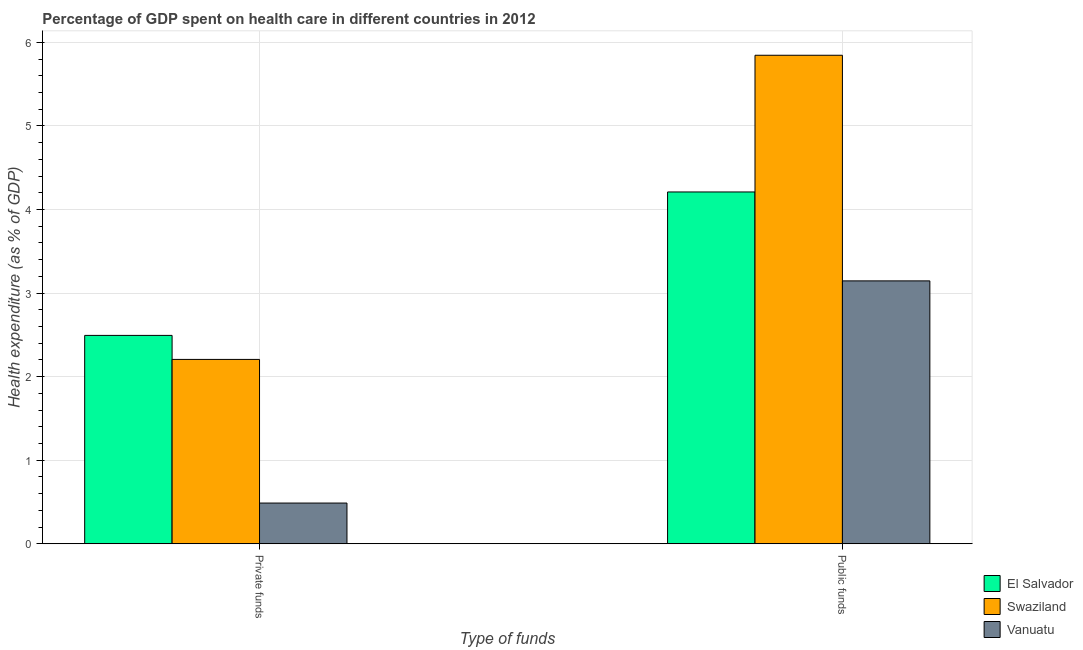How many groups of bars are there?
Offer a terse response. 2. Are the number of bars on each tick of the X-axis equal?
Provide a short and direct response. Yes. How many bars are there on the 1st tick from the left?
Provide a short and direct response. 3. What is the label of the 1st group of bars from the left?
Provide a succinct answer. Private funds. What is the amount of private funds spent in healthcare in El Salvador?
Provide a short and direct response. 2.49. Across all countries, what is the maximum amount of public funds spent in healthcare?
Offer a very short reply. 5.85. Across all countries, what is the minimum amount of public funds spent in healthcare?
Your answer should be very brief. 3.15. In which country was the amount of private funds spent in healthcare maximum?
Your answer should be compact. El Salvador. In which country was the amount of private funds spent in healthcare minimum?
Provide a short and direct response. Vanuatu. What is the total amount of private funds spent in healthcare in the graph?
Ensure brevity in your answer.  5.19. What is the difference between the amount of private funds spent in healthcare in Swaziland and that in Vanuatu?
Offer a terse response. 1.72. What is the difference between the amount of private funds spent in healthcare in Swaziland and the amount of public funds spent in healthcare in Vanuatu?
Your response must be concise. -0.94. What is the average amount of public funds spent in healthcare per country?
Your answer should be compact. 4.4. What is the difference between the amount of public funds spent in healthcare and amount of private funds spent in healthcare in Vanuatu?
Ensure brevity in your answer.  2.66. In how many countries, is the amount of public funds spent in healthcare greater than 5.8 %?
Make the answer very short. 1. What is the ratio of the amount of public funds spent in healthcare in Vanuatu to that in Swaziland?
Give a very brief answer. 0.54. Is the amount of private funds spent in healthcare in Swaziland less than that in Vanuatu?
Ensure brevity in your answer.  No. What does the 2nd bar from the left in Public funds represents?
Your answer should be very brief. Swaziland. What does the 3rd bar from the right in Public funds represents?
Your answer should be compact. El Salvador. Are all the bars in the graph horizontal?
Your answer should be compact. No. What is the difference between two consecutive major ticks on the Y-axis?
Keep it short and to the point. 1. Does the graph contain grids?
Provide a short and direct response. Yes. How many legend labels are there?
Provide a succinct answer. 3. How are the legend labels stacked?
Give a very brief answer. Vertical. What is the title of the graph?
Make the answer very short. Percentage of GDP spent on health care in different countries in 2012. What is the label or title of the X-axis?
Your answer should be compact. Type of funds. What is the label or title of the Y-axis?
Make the answer very short. Health expenditure (as % of GDP). What is the Health expenditure (as % of GDP) of El Salvador in Private funds?
Offer a terse response. 2.49. What is the Health expenditure (as % of GDP) in Swaziland in Private funds?
Make the answer very short. 2.21. What is the Health expenditure (as % of GDP) of Vanuatu in Private funds?
Provide a short and direct response. 0.49. What is the Health expenditure (as % of GDP) of El Salvador in Public funds?
Provide a succinct answer. 4.21. What is the Health expenditure (as % of GDP) in Swaziland in Public funds?
Offer a very short reply. 5.85. What is the Health expenditure (as % of GDP) in Vanuatu in Public funds?
Offer a very short reply. 3.15. Across all Type of funds, what is the maximum Health expenditure (as % of GDP) in El Salvador?
Provide a succinct answer. 4.21. Across all Type of funds, what is the maximum Health expenditure (as % of GDP) of Swaziland?
Make the answer very short. 5.85. Across all Type of funds, what is the maximum Health expenditure (as % of GDP) in Vanuatu?
Provide a succinct answer. 3.15. Across all Type of funds, what is the minimum Health expenditure (as % of GDP) in El Salvador?
Provide a short and direct response. 2.49. Across all Type of funds, what is the minimum Health expenditure (as % of GDP) of Swaziland?
Make the answer very short. 2.21. Across all Type of funds, what is the minimum Health expenditure (as % of GDP) in Vanuatu?
Give a very brief answer. 0.49. What is the total Health expenditure (as % of GDP) of El Salvador in the graph?
Provide a short and direct response. 6.7. What is the total Health expenditure (as % of GDP) of Swaziland in the graph?
Offer a terse response. 8.05. What is the total Health expenditure (as % of GDP) in Vanuatu in the graph?
Offer a terse response. 3.63. What is the difference between the Health expenditure (as % of GDP) in El Salvador in Private funds and that in Public funds?
Give a very brief answer. -1.72. What is the difference between the Health expenditure (as % of GDP) in Swaziland in Private funds and that in Public funds?
Your answer should be very brief. -3.64. What is the difference between the Health expenditure (as % of GDP) of Vanuatu in Private funds and that in Public funds?
Provide a short and direct response. -2.66. What is the difference between the Health expenditure (as % of GDP) in El Salvador in Private funds and the Health expenditure (as % of GDP) in Swaziland in Public funds?
Provide a succinct answer. -3.35. What is the difference between the Health expenditure (as % of GDP) in El Salvador in Private funds and the Health expenditure (as % of GDP) in Vanuatu in Public funds?
Provide a short and direct response. -0.65. What is the difference between the Health expenditure (as % of GDP) of Swaziland in Private funds and the Health expenditure (as % of GDP) of Vanuatu in Public funds?
Make the answer very short. -0.94. What is the average Health expenditure (as % of GDP) in El Salvador per Type of funds?
Make the answer very short. 3.35. What is the average Health expenditure (as % of GDP) in Swaziland per Type of funds?
Offer a very short reply. 4.03. What is the average Health expenditure (as % of GDP) in Vanuatu per Type of funds?
Keep it short and to the point. 1.82. What is the difference between the Health expenditure (as % of GDP) of El Salvador and Health expenditure (as % of GDP) of Swaziland in Private funds?
Provide a short and direct response. 0.29. What is the difference between the Health expenditure (as % of GDP) of El Salvador and Health expenditure (as % of GDP) of Vanuatu in Private funds?
Make the answer very short. 2.01. What is the difference between the Health expenditure (as % of GDP) in Swaziland and Health expenditure (as % of GDP) in Vanuatu in Private funds?
Keep it short and to the point. 1.72. What is the difference between the Health expenditure (as % of GDP) in El Salvador and Health expenditure (as % of GDP) in Swaziland in Public funds?
Your answer should be very brief. -1.64. What is the difference between the Health expenditure (as % of GDP) in El Salvador and Health expenditure (as % of GDP) in Vanuatu in Public funds?
Give a very brief answer. 1.06. What is the difference between the Health expenditure (as % of GDP) in Swaziland and Health expenditure (as % of GDP) in Vanuatu in Public funds?
Your response must be concise. 2.7. What is the ratio of the Health expenditure (as % of GDP) in El Salvador in Private funds to that in Public funds?
Your answer should be compact. 0.59. What is the ratio of the Health expenditure (as % of GDP) of Swaziland in Private funds to that in Public funds?
Offer a very short reply. 0.38. What is the ratio of the Health expenditure (as % of GDP) of Vanuatu in Private funds to that in Public funds?
Ensure brevity in your answer.  0.15. What is the difference between the highest and the second highest Health expenditure (as % of GDP) in El Salvador?
Keep it short and to the point. 1.72. What is the difference between the highest and the second highest Health expenditure (as % of GDP) of Swaziland?
Offer a very short reply. 3.64. What is the difference between the highest and the second highest Health expenditure (as % of GDP) in Vanuatu?
Your response must be concise. 2.66. What is the difference between the highest and the lowest Health expenditure (as % of GDP) of El Salvador?
Offer a terse response. 1.72. What is the difference between the highest and the lowest Health expenditure (as % of GDP) of Swaziland?
Make the answer very short. 3.64. What is the difference between the highest and the lowest Health expenditure (as % of GDP) in Vanuatu?
Your answer should be very brief. 2.66. 